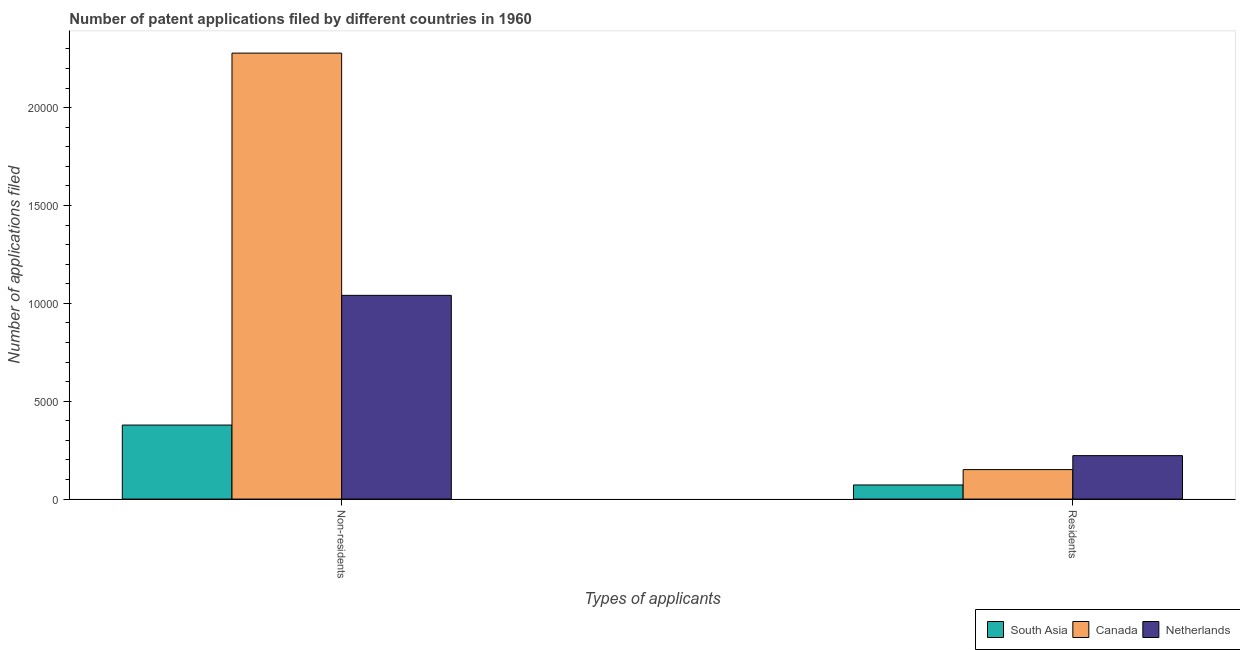Are the number of bars on each tick of the X-axis equal?
Offer a terse response. Yes. What is the label of the 2nd group of bars from the left?
Your answer should be compact. Residents. What is the number of patent applications by residents in Canada?
Offer a terse response. 1506. Across all countries, what is the maximum number of patent applications by residents?
Provide a short and direct response. 2220. Across all countries, what is the minimum number of patent applications by residents?
Your answer should be very brief. 721. In which country was the number of patent applications by residents maximum?
Provide a short and direct response. Netherlands. In which country was the number of patent applications by residents minimum?
Give a very brief answer. South Asia. What is the total number of patent applications by non residents in the graph?
Offer a very short reply. 3.70e+04. What is the difference between the number of patent applications by non residents in Canada and that in South Asia?
Your answer should be very brief. 1.90e+04. What is the difference between the number of patent applications by residents in Canada and the number of patent applications by non residents in Netherlands?
Offer a terse response. -8903. What is the average number of patent applications by residents per country?
Keep it short and to the point. 1482.33. What is the difference between the number of patent applications by non residents and number of patent applications by residents in Canada?
Give a very brief answer. 2.13e+04. What is the ratio of the number of patent applications by non residents in South Asia to that in Canada?
Provide a short and direct response. 0.17. Is the number of patent applications by residents in Canada less than that in Netherlands?
Provide a short and direct response. Yes. In how many countries, is the number of patent applications by residents greater than the average number of patent applications by residents taken over all countries?
Your answer should be compact. 2. What does the 3rd bar from the right in Residents represents?
Keep it short and to the point. South Asia. How many countries are there in the graph?
Your answer should be compact. 3. What is the difference between two consecutive major ticks on the Y-axis?
Ensure brevity in your answer.  5000. Are the values on the major ticks of Y-axis written in scientific E-notation?
Give a very brief answer. No. Does the graph contain grids?
Provide a short and direct response. No. Where does the legend appear in the graph?
Your answer should be very brief. Bottom right. How many legend labels are there?
Make the answer very short. 3. What is the title of the graph?
Keep it short and to the point. Number of patent applications filed by different countries in 1960. What is the label or title of the X-axis?
Your answer should be very brief. Types of applicants. What is the label or title of the Y-axis?
Your answer should be very brief. Number of applications filed. What is the Number of applications filed of South Asia in Non-residents?
Give a very brief answer. 3782. What is the Number of applications filed in Canada in Non-residents?
Give a very brief answer. 2.28e+04. What is the Number of applications filed in Netherlands in Non-residents?
Ensure brevity in your answer.  1.04e+04. What is the Number of applications filed of South Asia in Residents?
Give a very brief answer. 721. What is the Number of applications filed of Canada in Residents?
Ensure brevity in your answer.  1506. What is the Number of applications filed of Netherlands in Residents?
Your response must be concise. 2220. Across all Types of applicants, what is the maximum Number of applications filed in South Asia?
Give a very brief answer. 3782. Across all Types of applicants, what is the maximum Number of applications filed of Canada?
Offer a terse response. 2.28e+04. Across all Types of applicants, what is the maximum Number of applications filed in Netherlands?
Provide a succinct answer. 1.04e+04. Across all Types of applicants, what is the minimum Number of applications filed in South Asia?
Ensure brevity in your answer.  721. Across all Types of applicants, what is the minimum Number of applications filed in Canada?
Your answer should be compact. 1506. Across all Types of applicants, what is the minimum Number of applications filed in Netherlands?
Give a very brief answer. 2220. What is the total Number of applications filed in South Asia in the graph?
Make the answer very short. 4503. What is the total Number of applications filed of Canada in the graph?
Provide a short and direct response. 2.43e+04. What is the total Number of applications filed in Netherlands in the graph?
Ensure brevity in your answer.  1.26e+04. What is the difference between the Number of applications filed of South Asia in Non-residents and that in Residents?
Provide a short and direct response. 3061. What is the difference between the Number of applications filed of Canada in Non-residents and that in Residents?
Ensure brevity in your answer.  2.13e+04. What is the difference between the Number of applications filed in Netherlands in Non-residents and that in Residents?
Offer a very short reply. 8189. What is the difference between the Number of applications filed of South Asia in Non-residents and the Number of applications filed of Canada in Residents?
Provide a short and direct response. 2276. What is the difference between the Number of applications filed in South Asia in Non-residents and the Number of applications filed in Netherlands in Residents?
Offer a terse response. 1562. What is the difference between the Number of applications filed in Canada in Non-residents and the Number of applications filed in Netherlands in Residents?
Your answer should be compact. 2.06e+04. What is the average Number of applications filed of South Asia per Types of applicants?
Give a very brief answer. 2251.5. What is the average Number of applications filed in Canada per Types of applicants?
Ensure brevity in your answer.  1.21e+04. What is the average Number of applications filed of Netherlands per Types of applicants?
Ensure brevity in your answer.  6314.5. What is the difference between the Number of applications filed of South Asia and Number of applications filed of Canada in Non-residents?
Make the answer very short. -1.90e+04. What is the difference between the Number of applications filed in South Asia and Number of applications filed in Netherlands in Non-residents?
Your answer should be compact. -6627. What is the difference between the Number of applications filed in Canada and Number of applications filed in Netherlands in Non-residents?
Provide a short and direct response. 1.24e+04. What is the difference between the Number of applications filed in South Asia and Number of applications filed in Canada in Residents?
Offer a very short reply. -785. What is the difference between the Number of applications filed of South Asia and Number of applications filed of Netherlands in Residents?
Offer a terse response. -1499. What is the difference between the Number of applications filed in Canada and Number of applications filed in Netherlands in Residents?
Offer a terse response. -714. What is the ratio of the Number of applications filed in South Asia in Non-residents to that in Residents?
Provide a succinct answer. 5.25. What is the ratio of the Number of applications filed of Canada in Non-residents to that in Residents?
Offer a very short reply. 15.13. What is the ratio of the Number of applications filed in Netherlands in Non-residents to that in Residents?
Your response must be concise. 4.69. What is the difference between the highest and the second highest Number of applications filed in South Asia?
Your answer should be very brief. 3061. What is the difference between the highest and the second highest Number of applications filed in Canada?
Offer a terse response. 2.13e+04. What is the difference between the highest and the second highest Number of applications filed of Netherlands?
Keep it short and to the point. 8189. What is the difference between the highest and the lowest Number of applications filed of South Asia?
Offer a very short reply. 3061. What is the difference between the highest and the lowest Number of applications filed in Canada?
Make the answer very short. 2.13e+04. What is the difference between the highest and the lowest Number of applications filed in Netherlands?
Ensure brevity in your answer.  8189. 